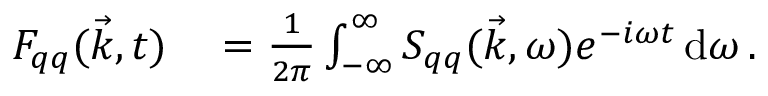Convert formula to latex. <formula><loc_0><loc_0><loc_500><loc_500>\begin{array} { r l } { F _ { q q } ( \vec { k } , t ) } & = \frac { 1 } { 2 \pi } \int _ { - \infty } ^ { \infty } S _ { q q } ( \vec { k } , \omega ) e ^ { - i \omega t } \, d \omega \, . } \end{array}</formula> 